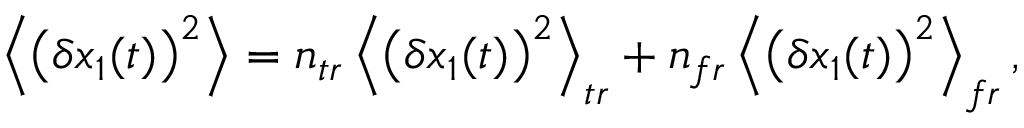Convert formula to latex. <formula><loc_0><loc_0><loc_500><loc_500>\left \langle \left ( \delta x _ { 1 } ( t ) \right ) ^ { 2 } \right \rangle = n _ { t r } \left \langle \left ( \delta x _ { 1 } ( t ) \right ) ^ { 2 } \right \rangle _ { t r } + n _ { f r } \left \langle \left ( \delta x _ { 1 } ( t ) \right ) ^ { 2 } \right \rangle _ { f r } ,</formula> 